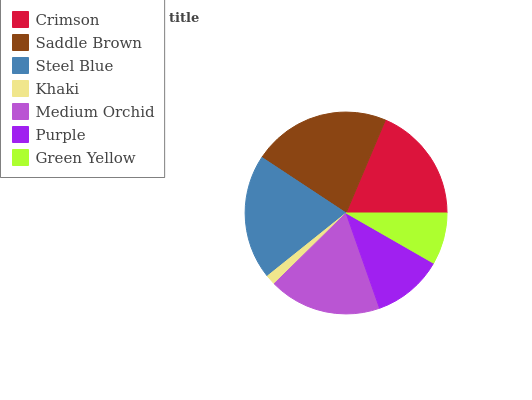Is Khaki the minimum?
Answer yes or no. Yes. Is Saddle Brown the maximum?
Answer yes or no. Yes. Is Steel Blue the minimum?
Answer yes or no. No. Is Steel Blue the maximum?
Answer yes or no. No. Is Saddle Brown greater than Steel Blue?
Answer yes or no. Yes. Is Steel Blue less than Saddle Brown?
Answer yes or no. Yes. Is Steel Blue greater than Saddle Brown?
Answer yes or no. No. Is Saddle Brown less than Steel Blue?
Answer yes or no. No. Is Medium Orchid the high median?
Answer yes or no. Yes. Is Medium Orchid the low median?
Answer yes or no. Yes. Is Saddle Brown the high median?
Answer yes or no. No. Is Steel Blue the low median?
Answer yes or no. No. 